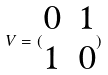Convert formula to latex. <formula><loc_0><loc_0><loc_500><loc_500>V = ( \begin{matrix} 0 & 1 \\ 1 & 0 \end{matrix} )</formula> 